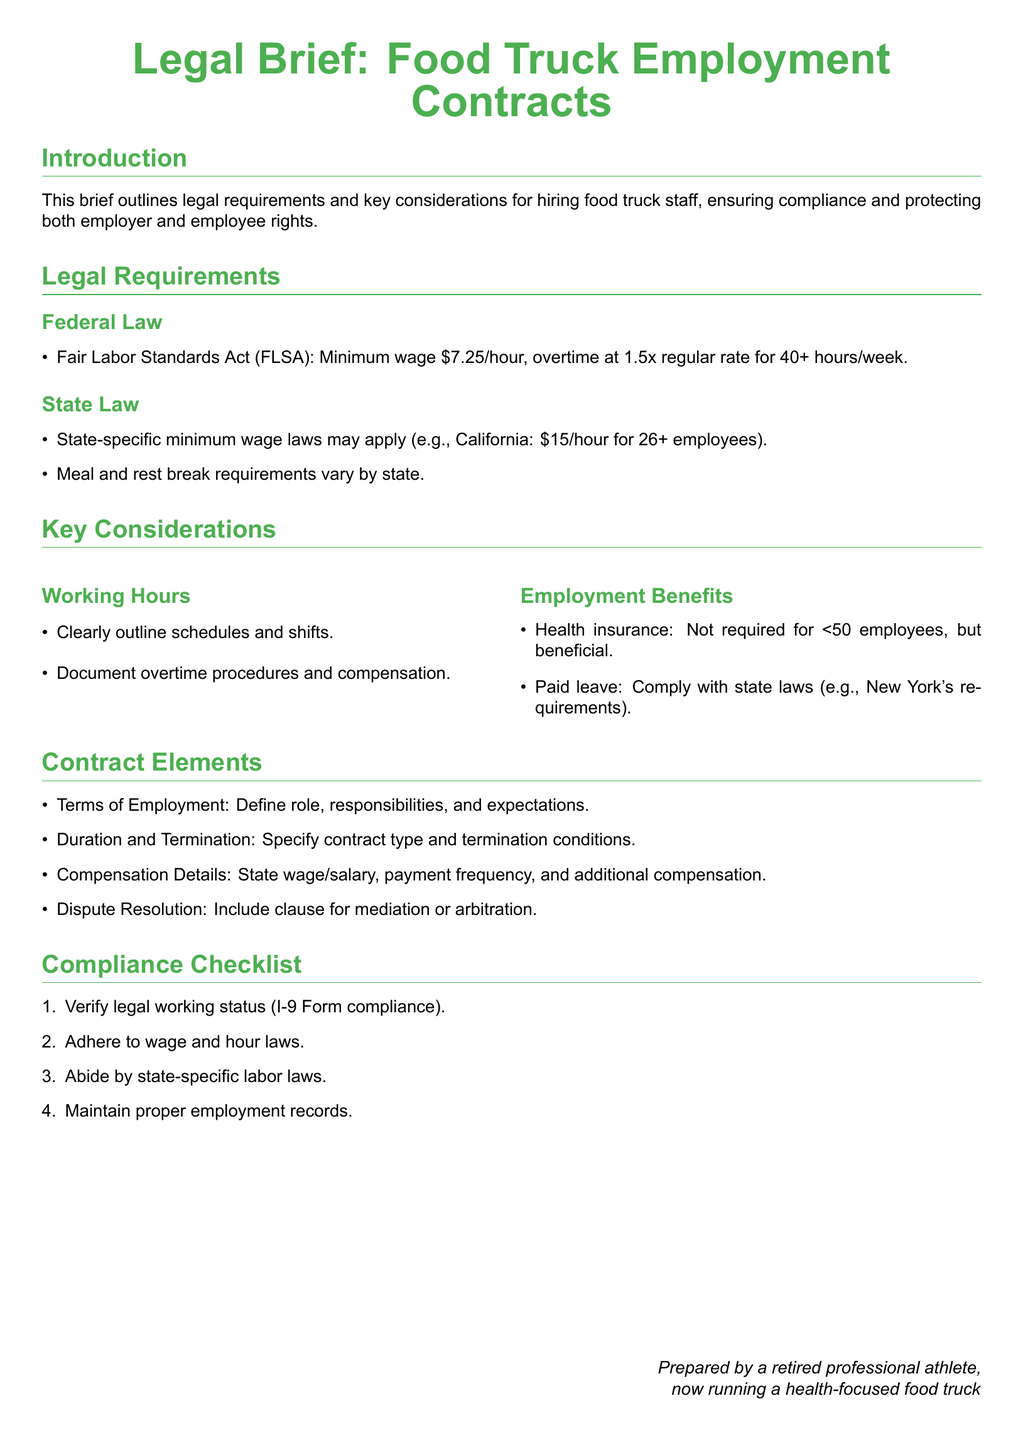what is the minimum wage required by federal law? The minimum wage required by federal law according to the Fair Labor Standards Act is $7.25/hour.
Answer: $7.25/hour what is the overtime pay rate for hours worked beyond 40 hours in a week? The overtime pay rate for hours worked beyond 40 hours in a week is 1.5 times the regular rate.
Answer: 1.5 times what is the state-specific minimum wage for California? The state-specific minimum wage for California for 26 or more employees is $15/hour.
Answer: $15/hour what does the employment benefits section mention about health insurance? The employment benefits section notes that health insurance is not required for businesses with fewer than 50 employees but is beneficial.
Answer: Not required what are the two key elements to be specified in a contract regarding employment duration? The two key elements to be specified regarding employment duration are contract type and termination conditions.
Answer: Contract type and termination conditions how many items are in the compliance checklist? The compliance checklist contains four items that must be adhered to by employers.
Answer: Four what should be included in the dispute resolution clause? The dispute resolution clause should include provisions for mediation or arbitration.
Answer: Mediation or arbitration what should employers ensure regarding work schedules? Employers should clearly outline schedules and shifts in the employment contracts.
Answer: Clearly outline schedules and shifts what is essential to document for employees working overtime? It is essential to document overtime procedures and compensation for employees working overtime.
Answer: Overtime procedures and compensation 